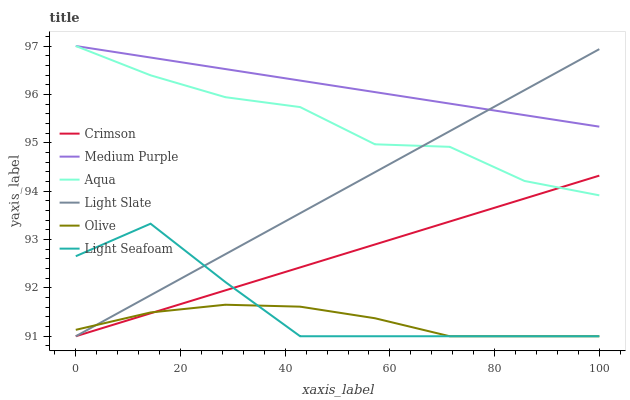Does Olive have the minimum area under the curve?
Answer yes or no. Yes. Does Medium Purple have the maximum area under the curve?
Answer yes or no. Yes. Does Aqua have the minimum area under the curve?
Answer yes or no. No. Does Aqua have the maximum area under the curve?
Answer yes or no. No. Is Medium Purple the smoothest?
Answer yes or no. Yes. Is Light Seafoam the roughest?
Answer yes or no. Yes. Is Aqua the smoothest?
Answer yes or no. No. Is Aqua the roughest?
Answer yes or no. No. Does Light Slate have the lowest value?
Answer yes or no. Yes. Does Aqua have the lowest value?
Answer yes or no. No. Does Medium Purple have the highest value?
Answer yes or no. Yes. Does Olive have the highest value?
Answer yes or no. No. Is Olive less than Medium Purple?
Answer yes or no. Yes. Is Medium Purple greater than Light Seafoam?
Answer yes or no. Yes. Does Light Slate intersect Light Seafoam?
Answer yes or no. Yes. Is Light Slate less than Light Seafoam?
Answer yes or no. No. Is Light Slate greater than Light Seafoam?
Answer yes or no. No. Does Olive intersect Medium Purple?
Answer yes or no. No. 